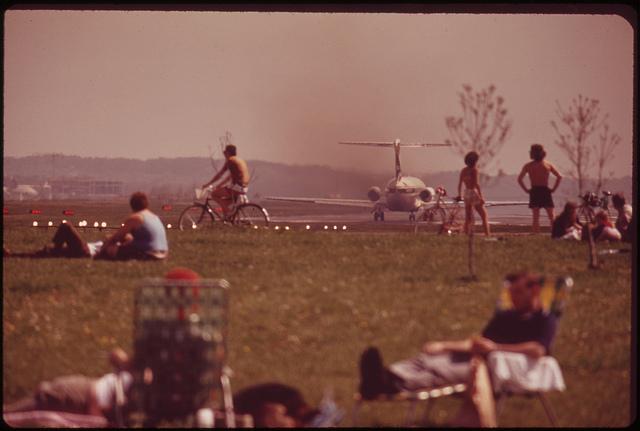Is it hot here?
Short answer required. Yes. Is this a romantic picture?
Be succinct. No. Is the airplane coming or going?
Answer briefly. Coming. How many people in this photo?
Give a very brief answer. 10. What type of sporting event are they attending?
Concise answer only. None. What color scheme was the photo taken in?
Short answer required. Color. Where are these people?
Quick response, please. Park. Is this a recent photo?
Write a very short answer. No. Who will be batting next?
Be succinct. Batter. Was the pic taken in the evening?
Quick response, please. Yes. 